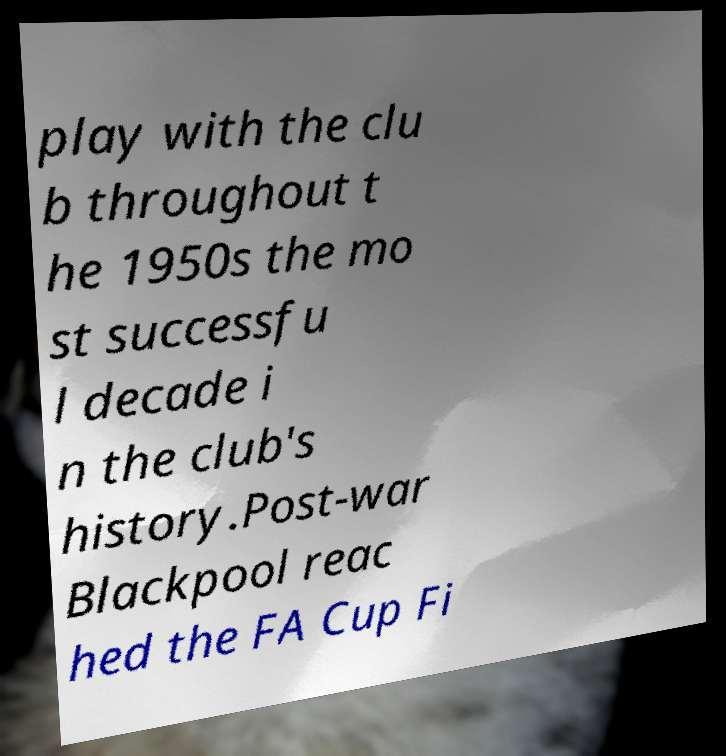Please identify and transcribe the text found in this image. play with the clu b throughout t he 1950s the mo st successfu l decade i n the club's history.Post-war Blackpool reac hed the FA Cup Fi 